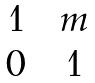Convert formula to latex. <formula><loc_0><loc_0><loc_500><loc_500>\begin{matrix} 1 & & m \\ 0 & & 1 \end{matrix}</formula> 